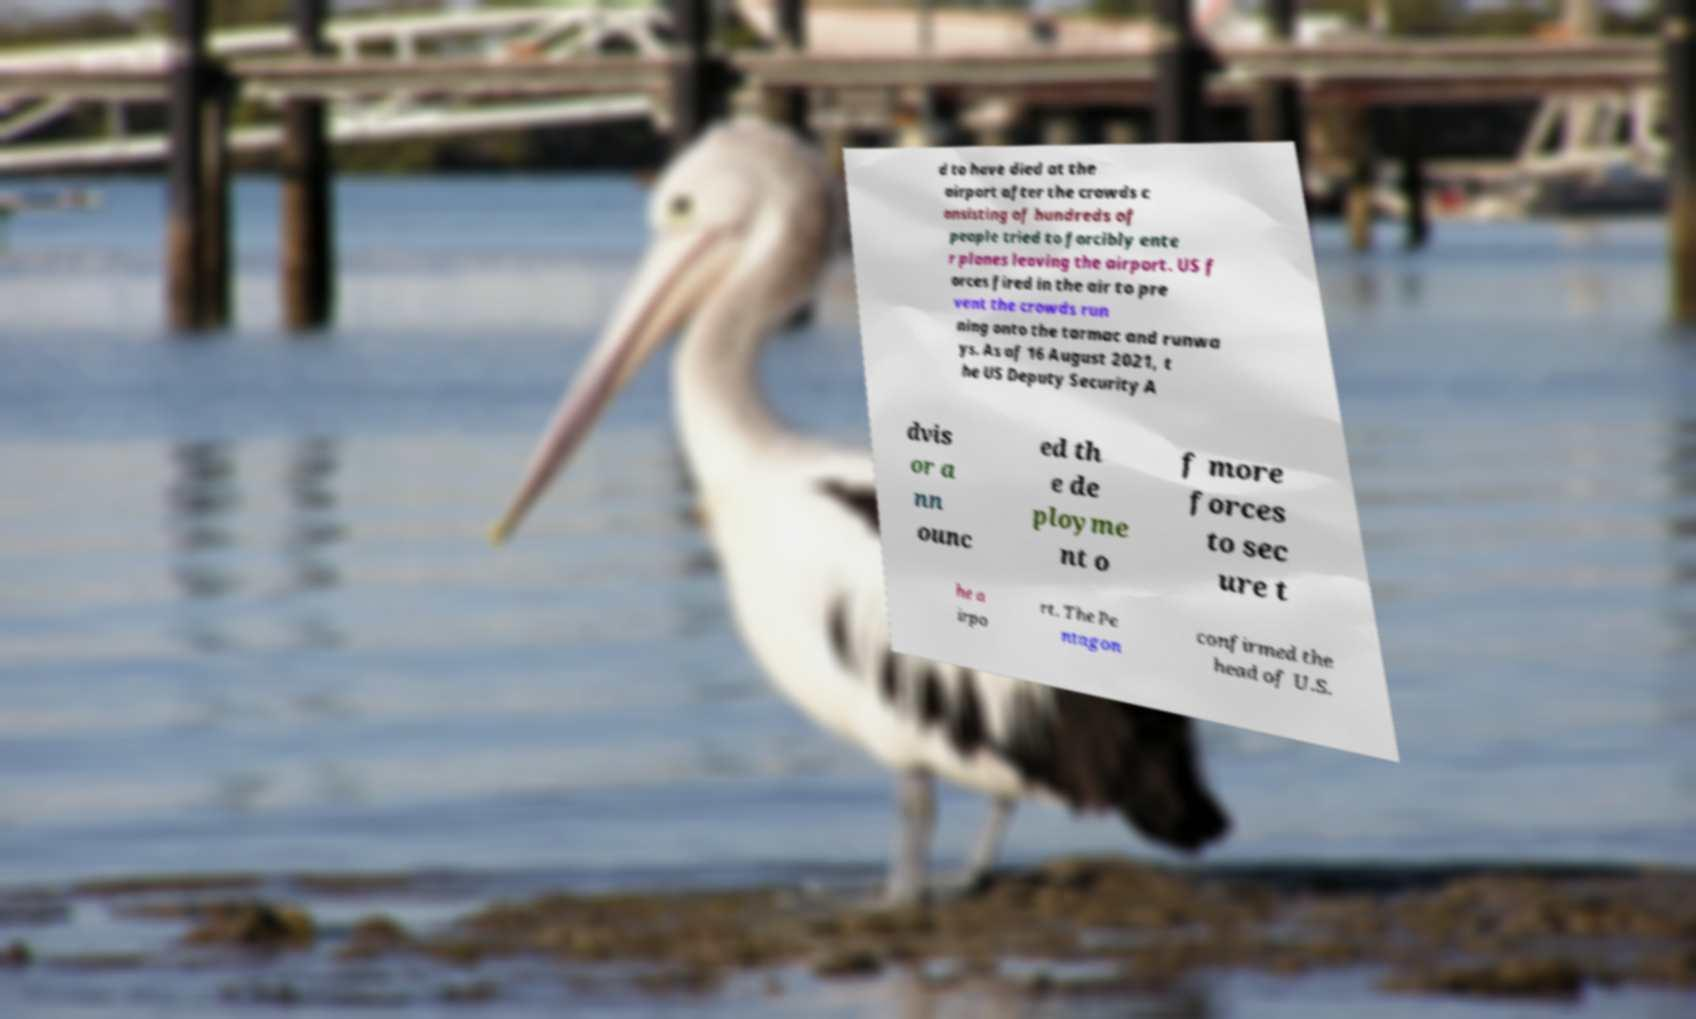Can you read and provide the text displayed in the image?This photo seems to have some interesting text. Can you extract and type it out for me? d to have died at the airport after the crowds c onsisting of hundreds of people tried to forcibly ente r planes leaving the airport. US f orces fired in the air to pre vent the crowds run ning onto the tarmac and runwa ys. As of 16 August 2021, t he US Deputy Security A dvis or a nn ounc ed th e de ployme nt o f more forces to sec ure t he a irpo rt. The Pe ntagon confirmed the head of U.S. 